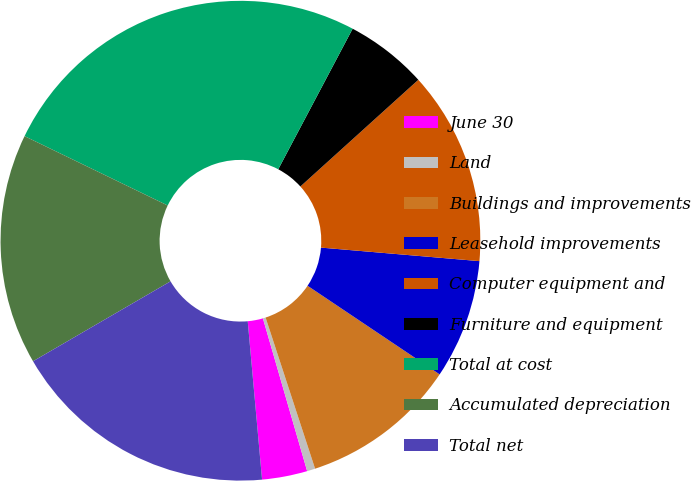<chart> <loc_0><loc_0><loc_500><loc_500><pie_chart><fcel>June 30<fcel>Land<fcel>Buildings and improvements<fcel>Leasehold improvements<fcel>Computer equipment and<fcel>Furniture and equipment<fcel>Total at cost<fcel>Accumulated depreciation<fcel>Total net<nl><fcel>3.05%<fcel>0.55%<fcel>10.56%<fcel>8.05%<fcel>13.06%<fcel>5.55%<fcel>25.57%<fcel>15.56%<fcel>18.06%<nl></chart> 